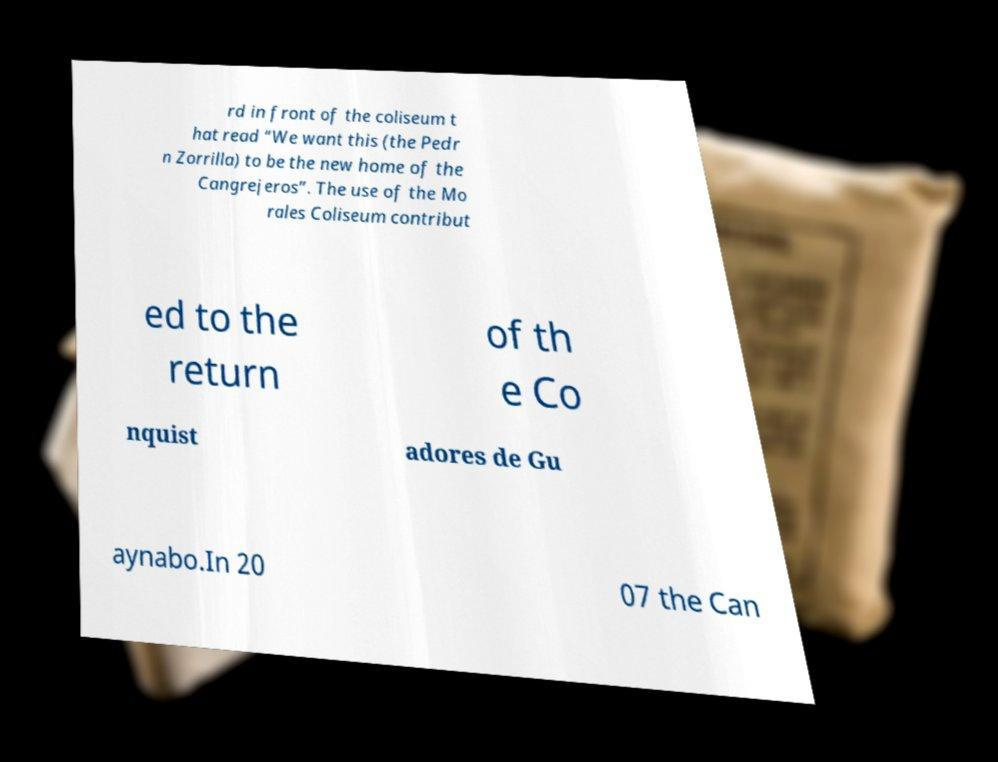Please identify and transcribe the text found in this image. rd in front of the coliseum t hat read “We want this (the Pedr n Zorrilla) to be the new home of the Cangrejeros”. The use of the Mo rales Coliseum contribut ed to the return of th e Co nquist adores de Gu aynabo.In 20 07 the Can 